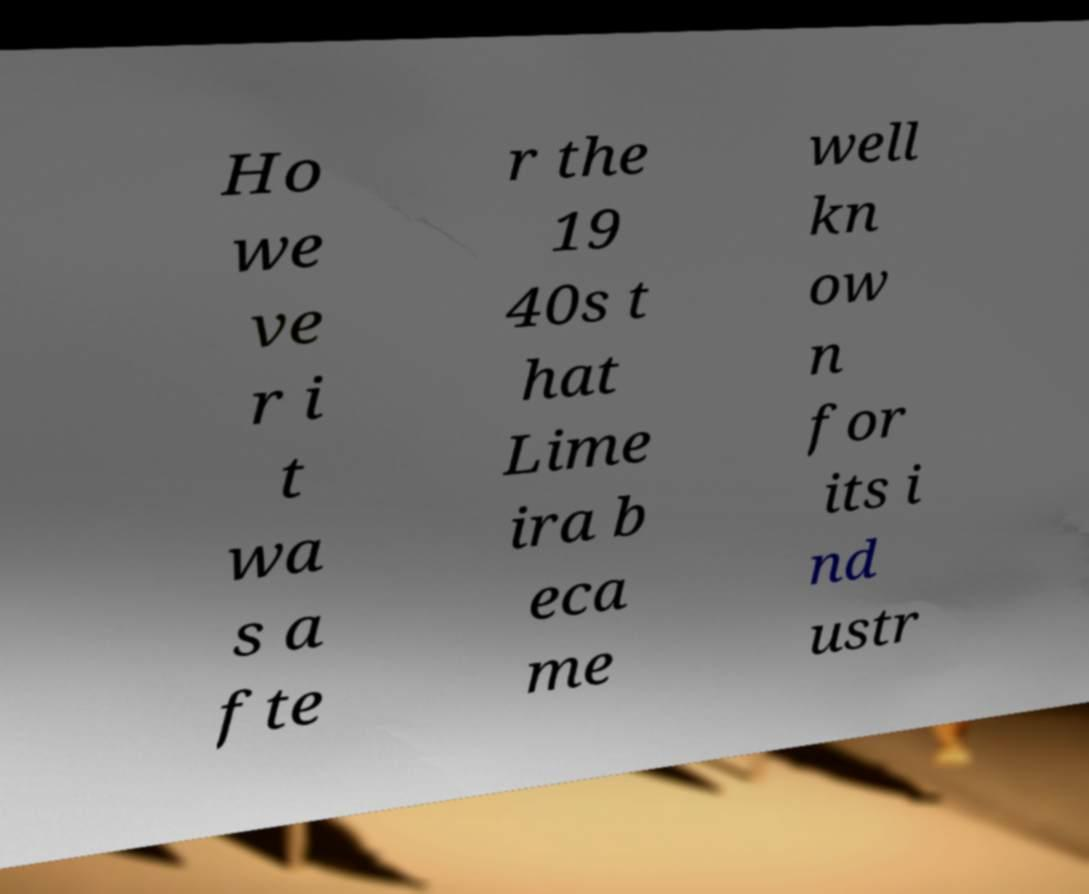Could you extract and type out the text from this image? Ho we ve r i t wa s a fte r the 19 40s t hat Lime ira b eca me well kn ow n for its i nd ustr 